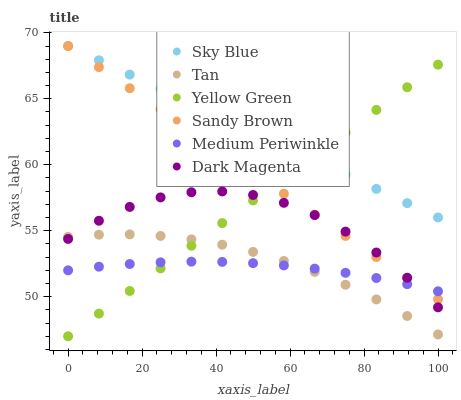Does Medium Periwinkle have the minimum area under the curve?
Answer yes or no. Yes. Does Sky Blue have the maximum area under the curve?
Answer yes or no. Yes. Does Sky Blue have the minimum area under the curve?
Answer yes or no. No. Does Medium Periwinkle have the maximum area under the curve?
Answer yes or no. No. Is Sky Blue the smoothest?
Answer yes or no. Yes. Is Dark Magenta the roughest?
Answer yes or no. Yes. Is Medium Periwinkle the smoothest?
Answer yes or no. No. Is Medium Periwinkle the roughest?
Answer yes or no. No. Does Yellow Green have the lowest value?
Answer yes or no. Yes. Does Medium Periwinkle have the lowest value?
Answer yes or no. No. Does Sandy Brown have the highest value?
Answer yes or no. Yes. Does Medium Periwinkle have the highest value?
Answer yes or no. No. Is Tan less than Sky Blue?
Answer yes or no. Yes. Is Sky Blue greater than Dark Magenta?
Answer yes or no. Yes. Does Sky Blue intersect Yellow Green?
Answer yes or no. Yes. Is Sky Blue less than Yellow Green?
Answer yes or no. No. Is Sky Blue greater than Yellow Green?
Answer yes or no. No. Does Tan intersect Sky Blue?
Answer yes or no. No. 